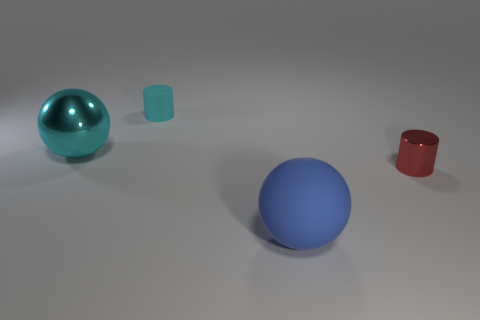Add 2 tiny shiny balls. How many objects exist? 6 Add 3 blue matte spheres. How many blue matte spheres exist? 4 Subtract 0 brown spheres. How many objects are left? 4 Subtract all tiny metal things. Subtract all small cyan matte cylinders. How many objects are left? 2 Add 3 big blue rubber balls. How many big blue rubber balls are left? 4 